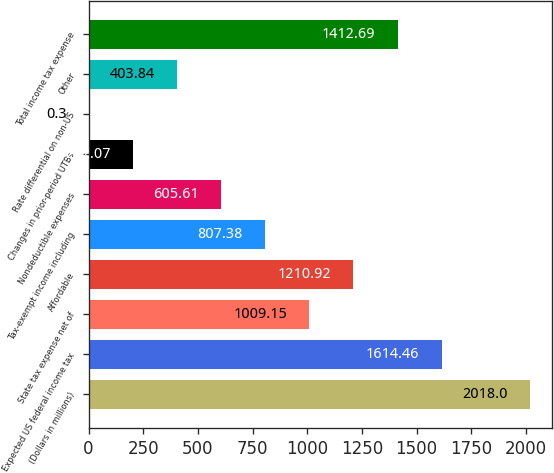Convert chart to OTSL. <chart><loc_0><loc_0><loc_500><loc_500><bar_chart><fcel>(Dollars in millions)<fcel>Expected US federal income tax<fcel>State tax expense net of<fcel>Affordable<fcel>Tax-exempt income including<fcel>Nondeductible expenses<fcel>Changes in prior-period UTBs<fcel>Rate differential on non-US<fcel>Other<fcel>Total income tax expense<nl><fcel>2018<fcel>1614.46<fcel>1009.15<fcel>1210.92<fcel>807.38<fcel>605.61<fcel>202.07<fcel>0.3<fcel>403.84<fcel>1412.69<nl></chart> 